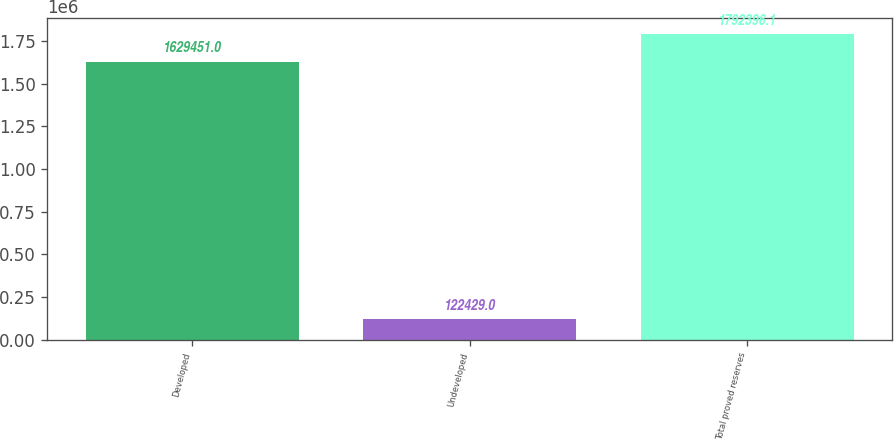Convert chart to OTSL. <chart><loc_0><loc_0><loc_500><loc_500><bar_chart><fcel>Developed<fcel>Undeveloped<fcel>Total proved reserves<nl><fcel>1.62945e+06<fcel>122429<fcel>1.7924e+06<nl></chart> 